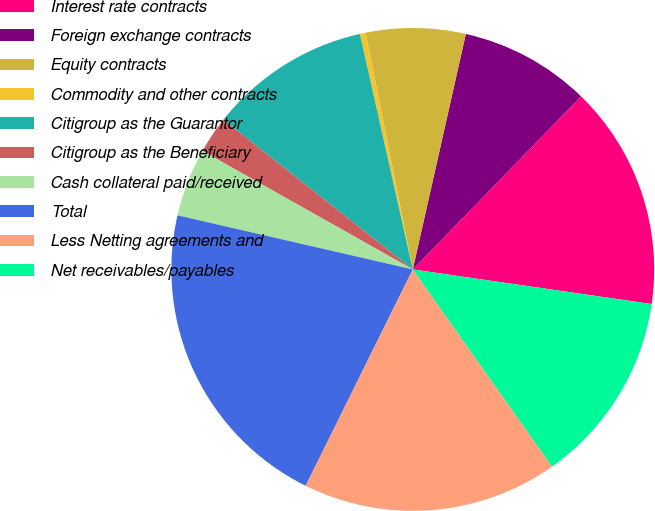<chart> <loc_0><loc_0><loc_500><loc_500><pie_chart><fcel>Interest rate contracts<fcel>Foreign exchange contracts<fcel>Equity contracts<fcel>Commodity and other contracts<fcel>Citigroup as the Guarantor<fcel>Citigroup as the Beneficiary<fcel>Cash collateral paid/received<fcel>Total<fcel>Less Netting agreements and<fcel>Net receivables/payables<nl><fcel>15.02%<fcel>8.75%<fcel>6.66%<fcel>0.39%<fcel>10.84%<fcel>2.48%<fcel>4.57%<fcel>21.29%<fcel>17.11%<fcel>12.93%<nl></chart> 